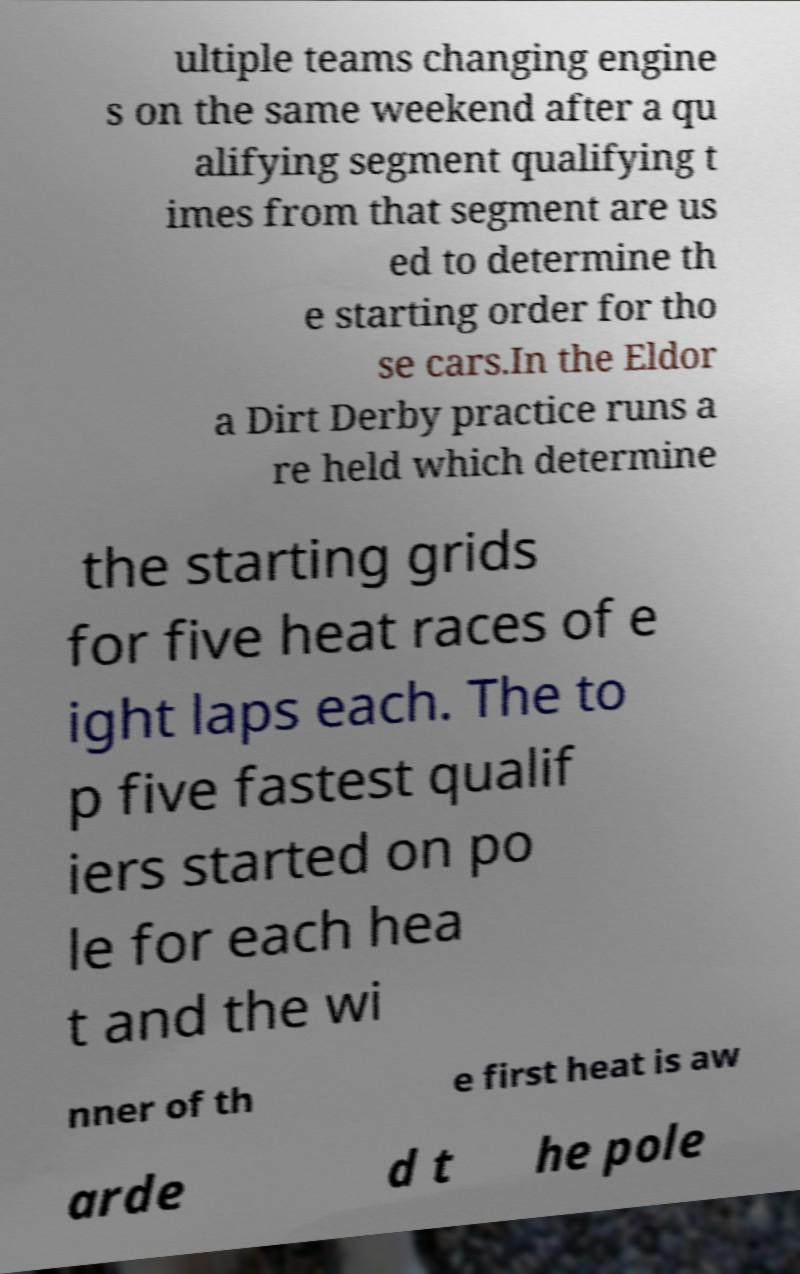Please identify and transcribe the text found in this image. ultiple teams changing engine s on the same weekend after a qu alifying segment qualifying t imes from that segment are us ed to determine th e starting order for tho se cars.In the Eldor a Dirt Derby practice runs a re held which determine the starting grids for five heat races of e ight laps each. The to p five fastest qualif iers started on po le for each hea t and the wi nner of th e first heat is aw arde d t he pole 